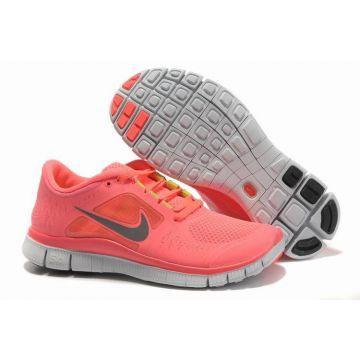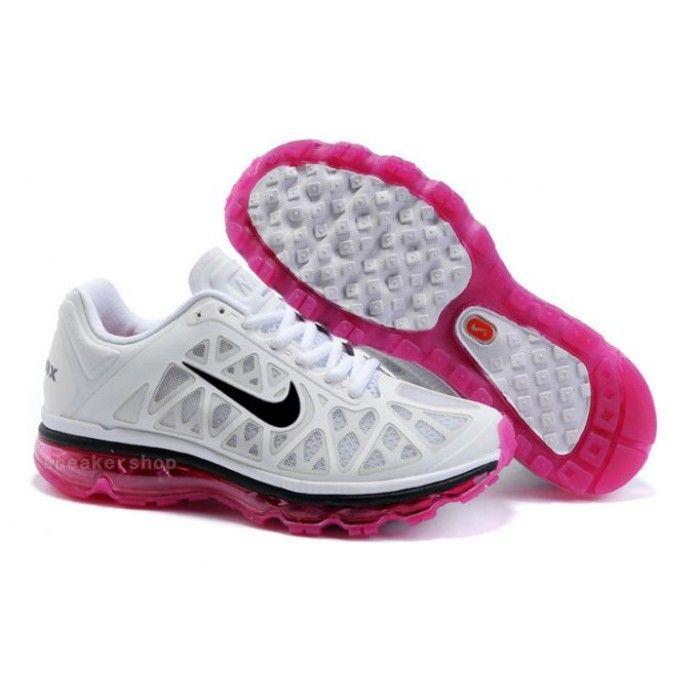The first image is the image on the left, the second image is the image on the right. Given the left and right images, does the statement "The bottom of a shoe sole is displayed facing the camera in each image." hold true? Answer yes or no. Yes. The first image is the image on the left, the second image is the image on the right. Evaluate the accuracy of this statement regarding the images: "Each image shows one laced-up shoe with a logo in profile, while a second shoe is angled behind it with the sole displayed.". Is it true? Answer yes or no. Yes. 